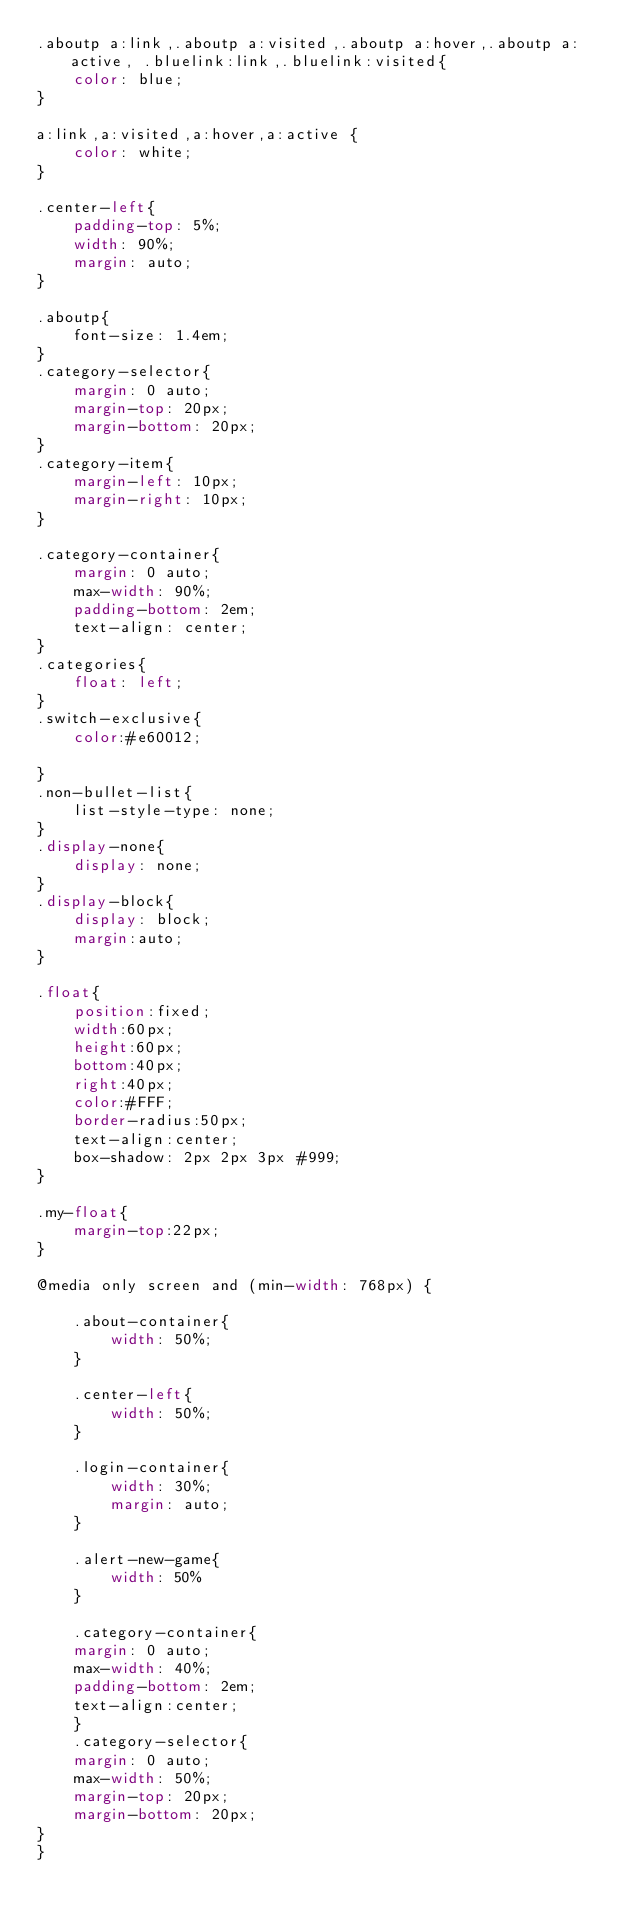<code> <loc_0><loc_0><loc_500><loc_500><_CSS_>.aboutp a:link,.aboutp a:visited,.aboutp a:hover,.aboutp a:active, .bluelink:link,.bluelink:visited{
    color: blue;
}

a:link,a:visited,a:hover,a:active {
    color: white;
}

.center-left{
    padding-top: 5%;
    width: 90%;
    margin: auto;
}

.aboutp{
    font-size: 1.4em;
}
.category-selector{
    margin: 0 auto;
    margin-top: 20px;
    margin-bottom: 20px;
}
.category-item{
    margin-left: 10px;
    margin-right: 10px;
}

.category-container{
    margin: 0 auto;
    max-width: 90%;
    padding-bottom: 2em;
    text-align: center;
}
.categories{
    float: left;
}
.switch-exclusive{
    color:#e60012;

}
.non-bullet-list{
    list-style-type: none;
}
.display-none{
    display: none;
}
.display-block{
    display: block;
    margin:auto;
}

.float{
    position:fixed;
    width:60px;
    height:60px;
    bottom:40px;
    right:40px;
    color:#FFF;
    border-radius:50px;
    text-align:center;
    box-shadow: 2px 2px 3px #999;
}

.my-float{
    margin-top:22px;
}

@media only screen and (min-width: 768px) {

    .about-container{
        width: 50%;
    }

    .center-left{
        width: 50%;
    }

    .login-container{
        width: 30%;
        margin: auto;
    }

    .alert-new-game{
        width: 50%
    }

    .category-container{
    margin: 0 auto;
    max-width: 40%;
    padding-bottom: 2em;
    text-align:center;
    }
    .category-selector{
    margin: 0 auto;
    max-width: 50%;
    margin-top: 20px;
    margin-bottom: 20px;
}
}</code> 